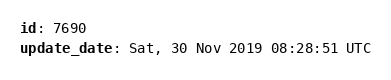<code> <loc_0><loc_0><loc_500><loc_500><_YAML_>id: 7690
update_date: Sat, 30 Nov 2019 08:28:51 UTC
</code> 